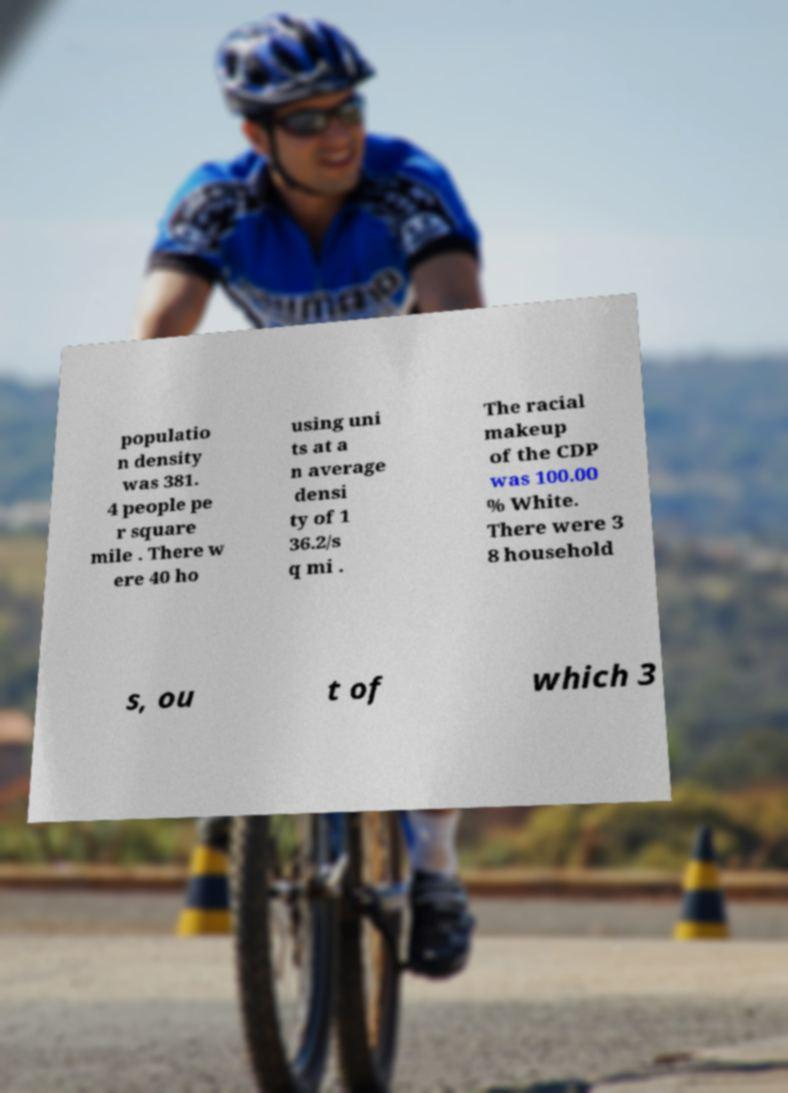There's text embedded in this image that I need extracted. Can you transcribe it verbatim? populatio n density was 381. 4 people pe r square mile . There w ere 40 ho using uni ts at a n average densi ty of 1 36.2/s q mi . The racial makeup of the CDP was 100.00 % White. There were 3 8 household s, ou t of which 3 